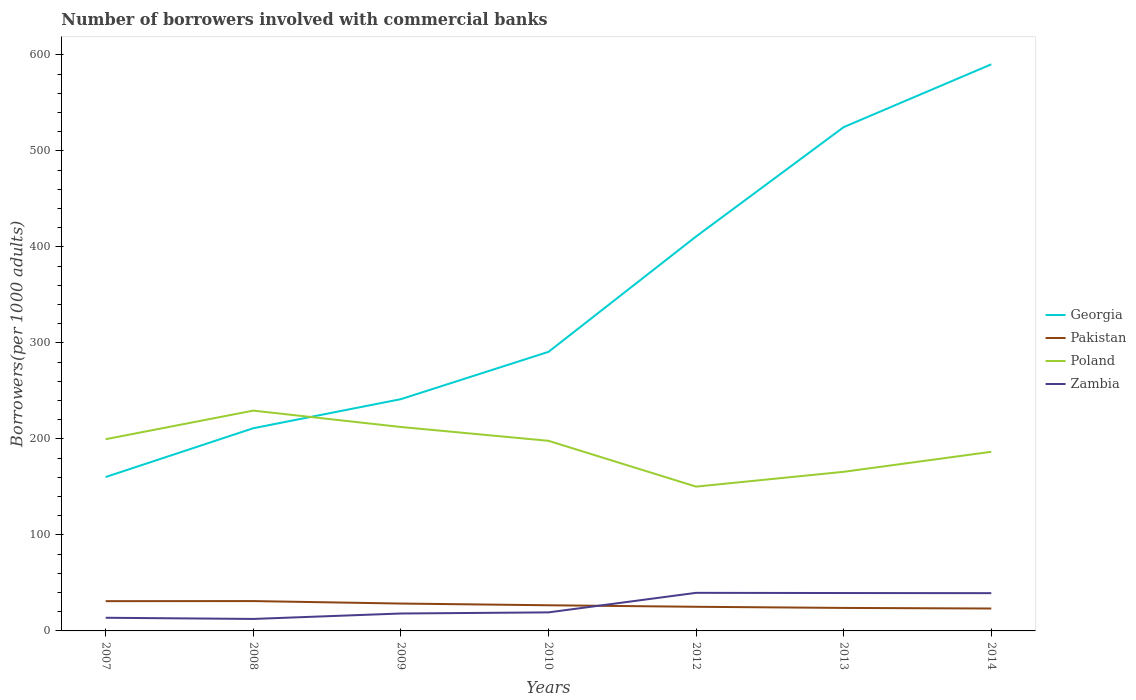Across all years, what is the maximum number of borrowers involved with commercial banks in Zambia?
Offer a very short reply. 12.48. In which year was the number of borrowers involved with commercial banks in Poland maximum?
Provide a short and direct response. 2012. What is the total number of borrowers involved with commercial banks in Zambia in the graph?
Provide a short and direct response. -25.97. What is the difference between the highest and the second highest number of borrowers involved with commercial banks in Zambia?
Ensure brevity in your answer.  27.2. What is the difference between the highest and the lowest number of borrowers involved with commercial banks in Poland?
Give a very brief answer. 4. Is the number of borrowers involved with commercial banks in Georgia strictly greater than the number of borrowers involved with commercial banks in Zambia over the years?
Provide a short and direct response. No. How many lines are there?
Ensure brevity in your answer.  4. How many years are there in the graph?
Provide a short and direct response. 7. Are the values on the major ticks of Y-axis written in scientific E-notation?
Provide a succinct answer. No. Does the graph contain any zero values?
Provide a short and direct response. No. How many legend labels are there?
Offer a terse response. 4. How are the legend labels stacked?
Provide a succinct answer. Vertical. What is the title of the graph?
Make the answer very short. Number of borrowers involved with commercial banks. Does "St. Kitts and Nevis" appear as one of the legend labels in the graph?
Provide a short and direct response. No. What is the label or title of the Y-axis?
Offer a terse response. Borrowers(per 1000 adults). What is the Borrowers(per 1000 adults) of Georgia in 2007?
Your answer should be compact. 160.33. What is the Borrowers(per 1000 adults) in Pakistan in 2007?
Provide a succinct answer. 31.01. What is the Borrowers(per 1000 adults) of Poland in 2007?
Provide a succinct answer. 199.74. What is the Borrowers(per 1000 adults) in Zambia in 2007?
Offer a terse response. 13.71. What is the Borrowers(per 1000 adults) of Georgia in 2008?
Offer a very short reply. 211.16. What is the Borrowers(per 1000 adults) of Pakistan in 2008?
Your answer should be compact. 31.09. What is the Borrowers(per 1000 adults) of Poland in 2008?
Keep it short and to the point. 229.51. What is the Borrowers(per 1000 adults) of Zambia in 2008?
Ensure brevity in your answer.  12.48. What is the Borrowers(per 1000 adults) in Georgia in 2009?
Your answer should be compact. 241.45. What is the Borrowers(per 1000 adults) in Pakistan in 2009?
Make the answer very short. 28.52. What is the Borrowers(per 1000 adults) of Poland in 2009?
Provide a short and direct response. 212.45. What is the Borrowers(per 1000 adults) of Zambia in 2009?
Provide a short and direct response. 18.15. What is the Borrowers(per 1000 adults) in Georgia in 2010?
Provide a succinct answer. 290.72. What is the Borrowers(per 1000 adults) of Pakistan in 2010?
Keep it short and to the point. 26.73. What is the Borrowers(per 1000 adults) of Poland in 2010?
Give a very brief answer. 198.06. What is the Borrowers(per 1000 adults) in Zambia in 2010?
Offer a terse response. 19.32. What is the Borrowers(per 1000 adults) in Georgia in 2012?
Make the answer very short. 410.92. What is the Borrowers(per 1000 adults) of Pakistan in 2012?
Provide a short and direct response. 25.15. What is the Borrowers(per 1000 adults) of Poland in 2012?
Give a very brief answer. 150.33. What is the Borrowers(per 1000 adults) of Zambia in 2012?
Offer a terse response. 39.68. What is the Borrowers(per 1000 adults) in Georgia in 2013?
Your answer should be very brief. 524.86. What is the Borrowers(per 1000 adults) of Pakistan in 2013?
Your response must be concise. 23.97. What is the Borrowers(per 1000 adults) of Poland in 2013?
Keep it short and to the point. 165.76. What is the Borrowers(per 1000 adults) of Zambia in 2013?
Give a very brief answer. 39.47. What is the Borrowers(per 1000 adults) in Georgia in 2014?
Offer a terse response. 590.3. What is the Borrowers(per 1000 adults) of Pakistan in 2014?
Your answer should be compact. 23.34. What is the Borrowers(per 1000 adults) in Poland in 2014?
Provide a succinct answer. 186.61. What is the Borrowers(per 1000 adults) of Zambia in 2014?
Your response must be concise. 39.34. Across all years, what is the maximum Borrowers(per 1000 adults) in Georgia?
Your answer should be very brief. 590.3. Across all years, what is the maximum Borrowers(per 1000 adults) in Pakistan?
Your answer should be very brief. 31.09. Across all years, what is the maximum Borrowers(per 1000 adults) of Poland?
Provide a succinct answer. 229.51. Across all years, what is the maximum Borrowers(per 1000 adults) of Zambia?
Ensure brevity in your answer.  39.68. Across all years, what is the minimum Borrowers(per 1000 adults) in Georgia?
Provide a succinct answer. 160.33. Across all years, what is the minimum Borrowers(per 1000 adults) of Pakistan?
Your answer should be compact. 23.34. Across all years, what is the minimum Borrowers(per 1000 adults) of Poland?
Keep it short and to the point. 150.33. Across all years, what is the minimum Borrowers(per 1000 adults) in Zambia?
Offer a terse response. 12.48. What is the total Borrowers(per 1000 adults) of Georgia in the graph?
Provide a short and direct response. 2429.75. What is the total Borrowers(per 1000 adults) in Pakistan in the graph?
Give a very brief answer. 189.81. What is the total Borrowers(per 1000 adults) in Poland in the graph?
Ensure brevity in your answer.  1342.47. What is the total Borrowers(per 1000 adults) in Zambia in the graph?
Offer a very short reply. 182.15. What is the difference between the Borrowers(per 1000 adults) in Georgia in 2007 and that in 2008?
Make the answer very short. -50.83. What is the difference between the Borrowers(per 1000 adults) of Pakistan in 2007 and that in 2008?
Offer a very short reply. -0.08. What is the difference between the Borrowers(per 1000 adults) of Poland in 2007 and that in 2008?
Your answer should be very brief. -29.78. What is the difference between the Borrowers(per 1000 adults) of Zambia in 2007 and that in 2008?
Your response must be concise. 1.22. What is the difference between the Borrowers(per 1000 adults) in Georgia in 2007 and that in 2009?
Your answer should be very brief. -81.12. What is the difference between the Borrowers(per 1000 adults) of Pakistan in 2007 and that in 2009?
Keep it short and to the point. 2.49. What is the difference between the Borrowers(per 1000 adults) of Poland in 2007 and that in 2009?
Your response must be concise. -12.71. What is the difference between the Borrowers(per 1000 adults) of Zambia in 2007 and that in 2009?
Your answer should be compact. -4.45. What is the difference between the Borrowers(per 1000 adults) in Georgia in 2007 and that in 2010?
Offer a very short reply. -130.39. What is the difference between the Borrowers(per 1000 adults) of Pakistan in 2007 and that in 2010?
Offer a very short reply. 4.29. What is the difference between the Borrowers(per 1000 adults) of Poland in 2007 and that in 2010?
Make the answer very short. 1.67. What is the difference between the Borrowers(per 1000 adults) in Zambia in 2007 and that in 2010?
Ensure brevity in your answer.  -5.62. What is the difference between the Borrowers(per 1000 adults) of Georgia in 2007 and that in 2012?
Give a very brief answer. -250.59. What is the difference between the Borrowers(per 1000 adults) in Pakistan in 2007 and that in 2012?
Your answer should be very brief. 5.87. What is the difference between the Borrowers(per 1000 adults) of Poland in 2007 and that in 2012?
Make the answer very short. 49.4. What is the difference between the Borrowers(per 1000 adults) of Zambia in 2007 and that in 2012?
Keep it short and to the point. -25.97. What is the difference between the Borrowers(per 1000 adults) in Georgia in 2007 and that in 2013?
Your answer should be compact. -364.53. What is the difference between the Borrowers(per 1000 adults) in Pakistan in 2007 and that in 2013?
Provide a short and direct response. 7.05. What is the difference between the Borrowers(per 1000 adults) in Poland in 2007 and that in 2013?
Your response must be concise. 33.97. What is the difference between the Borrowers(per 1000 adults) of Zambia in 2007 and that in 2013?
Give a very brief answer. -25.76. What is the difference between the Borrowers(per 1000 adults) in Georgia in 2007 and that in 2014?
Offer a terse response. -429.97. What is the difference between the Borrowers(per 1000 adults) of Pakistan in 2007 and that in 2014?
Provide a short and direct response. 7.67. What is the difference between the Borrowers(per 1000 adults) of Poland in 2007 and that in 2014?
Provide a succinct answer. 13.12. What is the difference between the Borrowers(per 1000 adults) of Zambia in 2007 and that in 2014?
Keep it short and to the point. -25.63. What is the difference between the Borrowers(per 1000 adults) of Georgia in 2008 and that in 2009?
Provide a short and direct response. -30.29. What is the difference between the Borrowers(per 1000 adults) in Pakistan in 2008 and that in 2009?
Give a very brief answer. 2.57. What is the difference between the Borrowers(per 1000 adults) of Poland in 2008 and that in 2009?
Offer a terse response. 17.07. What is the difference between the Borrowers(per 1000 adults) of Zambia in 2008 and that in 2009?
Provide a short and direct response. -5.67. What is the difference between the Borrowers(per 1000 adults) of Georgia in 2008 and that in 2010?
Your response must be concise. -79.56. What is the difference between the Borrowers(per 1000 adults) of Pakistan in 2008 and that in 2010?
Offer a very short reply. 4.36. What is the difference between the Borrowers(per 1000 adults) in Poland in 2008 and that in 2010?
Make the answer very short. 31.45. What is the difference between the Borrowers(per 1000 adults) in Zambia in 2008 and that in 2010?
Offer a terse response. -6.84. What is the difference between the Borrowers(per 1000 adults) in Georgia in 2008 and that in 2012?
Keep it short and to the point. -199.76. What is the difference between the Borrowers(per 1000 adults) in Pakistan in 2008 and that in 2012?
Keep it short and to the point. 5.94. What is the difference between the Borrowers(per 1000 adults) in Poland in 2008 and that in 2012?
Your response must be concise. 79.18. What is the difference between the Borrowers(per 1000 adults) of Zambia in 2008 and that in 2012?
Your answer should be compact. -27.2. What is the difference between the Borrowers(per 1000 adults) in Georgia in 2008 and that in 2013?
Provide a succinct answer. -313.7. What is the difference between the Borrowers(per 1000 adults) in Pakistan in 2008 and that in 2013?
Offer a terse response. 7.13. What is the difference between the Borrowers(per 1000 adults) in Poland in 2008 and that in 2013?
Offer a terse response. 63.75. What is the difference between the Borrowers(per 1000 adults) of Zambia in 2008 and that in 2013?
Your response must be concise. -26.98. What is the difference between the Borrowers(per 1000 adults) of Georgia in 2008 and that in 2014?
Your answer should be compact. -379.14. What is the difference between the Borrowers(per 1000 adults) in Pakistan in 2008 and that in 2014?
Provide a short and direct response. 7.75. What is the difference between the Borrowers(per 1000 adults) of Poland in 2008 and that in 2014?
Ensure brevity in your answer.  42.9. What is the difference between the Borrowers(per 1000 adults) in Zambia in 2008 and that in 2014?
Offer a very short reply. -26.86. What is the difference between the Borrowers(per 1000 adults) in Georgia in 2009 and that in 2010?
Provide a succinct answer. -49.27. What is the difference between the Borrowers(per 1000 adults) in Pakistan in 2009 and that in 2010?
Offer a terse response. 1.79. What is the difference between the Borrowers(per 1000 adults) in Poland in 2009 and that in 2010?
Provide a short and direct response. 14.38. What is the difference between the Borrowers(per 1000 adults) of Zambia in 2009 and that in 2010?
Provide a succinct answer. -1.17. What is the difference between the Borrowers(per 1000 adults) of Georgia in 2009 and that in 2012?
Your answer should be very brief. -169.47. What is the difference between the Borrowers(per 1000 adults) in Pakistan in 2009 and that in 2012?
Your answer should be very brief. 3.37. What is the difference between the Borrowers(per 1000 adults) in Poland in 2009 and that in 2012?
Offer a very short reply. 62.11. What is the difference between the Borrowers(per 1000 adults) of Zambia in 2009 and that in 2012?
Give a very brief answer. -21.52. What is the difference between the Borrowers(per 1000 adults) of Georgia in 2009 and that in 2013?
Your answer should be compact. -283.41. What is the difference between the Borrowers(per 1000 adults) in Pakistan in 2009 and that in 2013?
Offer a terse response. 4.55. What is the difference between the Borrowers(per 1000 adults) of Poland in 2009 and that in 2013?
Provide a short and direct response. 46.68. What is the difference between the Borrowers(per 1000 adults) of Zambia in 2009 and that in 2013?
Keep it short and to the point. -21.31. What is the difference between the Borrowers(per 1000 adults) of Georgia in 2009 and that in 2014?
Offer a terse response. -348.85. What is the difference between the Borrowers(per 1000 adults) of Pakistan in 2009 and that in 2014?
Keep it short and to the point. 5.18. What is the difference between the Borrowers(per 1000 adults) in Poland in 2009 and that in 2014?
Make the answer very short. 25.83. What is the difference between the Borrowers(per 1000 adults) of Zambia in 2009 and that in 2014?
Your answer should be compact. -21.19. What is the difference between the Borrowers(per 1000 adults) in Georgia in 2010 and that in 2012?
Your response must be concise. -120.2. What is the difference between the Borrowers(per 1000 adults) in Pakistan in 2010 and that in 2012?
Keep it short and to the point. 1.58. What is the difference between the Borrowers(per 1000 adults) in Poland in 2010 and that in 2012?
Your response must be concise. 47.73. What is the difference between the Borrowers(per 1000 adults) in Zambia in 2010 and that in 2012?
Keep it short and to the point. -20.36. What is the difference between the Borrowers(per 1000 adults) in Georgia in 2010 and that in 2013?
Offer a terse response. -234.14. What is the difference between the Borrowers(per 1000 adults) of Pakistan in 2010 and that in 2013?
Make the answer very short. 2.76. What is the difference between the Borrowers(per 1000 adults) of Poland in 2010 and that in 2013?
Provide a succinct answer. 32.3. What is the difference between the Borrowers(per 1000 adults) of Zambia in 2010 and that in 2013?
Make the answer very short. -20.14. What is the difference between the Borrowers(per 1000 adults) of Georgia in 2010 and that in 2014?
Your answer should be compact. -299.58. What is the difference between the Borrowers(per 1000 adults) of Pakistan in 2010 and that in 2014?
Your response must be concise. 3.39. What is the difference between the Borrowers(per 1000 adults) of Poland in 2010 and that in 2014?
Offer a very short reply. 11.45. What is the difference between the Borrowers(per 1000 adults) of Zambia in 2010 and that in 2014?
Keep it short and to the point. -20.02. What is the difference between the Borrowers(per 1000 adults) in Georgia in 2012 and that in 2013?
Keep it short and to the point. -113.94. What is the difference between the Borrowers(per 1000 adults) in Pakistan in 2012 and that in 2013?
Offer a very short reply. 1.18. What is the difference between the Borrowers(per 1000 adults) in Poland in 2012 and that in 2013?
Offer a terse response. -15.43. What is the difference between the Borrowers(per 1000 adults) in Zambia in 2012 and that in 2013?
Provide a short and direct response. 0.21. What is the difference between the Borrowers(per 1000 adults) in Georgia in 2012 and that in 2014?
Keep it short and to the point. -179.38. What is the difference between the Borrowers(per 1000 adults) of Pakistan in 2012 and that in 2014?
Keep it short and to the point. 1.81. What is the difference between the Borrowers(per 1000 adults) in Poland in 2012 and that in 2014?
Make the answer very short. -36.28. What is the difference between the Borrowers(per 1000 adults) in Zambia in 2012 and that in 2014?
Provide a short and direct response. 0.34. What is the difference between the Borrowers(per 1000 adults) in Georgia in 2013 and that in 2014?
Provide a succinct answer. -65.44. What is the difference between the Borrowers(per 1000 adults) of Pakistan in 2013 and that in 2014?
Your response must be concise. 0.63. What is the difference between the Borrowers(per 1000 adults) of Poland in 2013 and that in 2014?
Offer a terse response. -20.85. What is the difference between the Borrowers(per 1000 adults) in Zambia in 2013 and that in 2014?
Make the answer very short. 0.13. What is the difference between the Borrowers(per 1000 adults) in Georgia in 2007 and the Borrowers(per 1000 adults) in Pakistan in 2008?
Give a very brief answer. 129.24. What is the difference between the Borrowers(per 1000 adults) in Georgia in 2007 and the Borrowers(per 1000 adults) in Poland in 2008?
Provide a short and direct response. -69.18. What is the difference between the Borrowers(per 1000 adults) in Georgia in 2007 and the Borrowers(per 1000 adults) in Zambia in 2008?
Make the answer very short. 147.85. What is the difference between the Borrowers(per 1000 adults) in Pakistan in 2007 and the Borrowers(per 1000 adults) in Poland in 2008?
Provide a short and direct response. -198.5. What is the difference between the Borrowers(per 1000 adults) of Pakistan in 2007 and the Borrowers(per 1000 adults) of Zambia in 2008?
Give a very brief answer. 18.53. What is the difference between the Borrowers(per 1000 adults) of Poland in 2007 and the Borrowers(per 1000 adults) of Zambia in 2008?
Give a very brief answer. 187.25. What is the difference between the Borrowers(per 1000 adults) of Georgia in 2007 and the Borrowers(per 1000 adults) of Pakistan in 2009?
Your answer should be very brief. 131.81. What is the difference between the Borrowers(per 1000 adults) in Georgia in 2007 and the Borrowers(per 1000 adults) in Poland in 2009?
Give a very brief answer. -52.11. What is the difference between the Borrowers(per 1000 adults) in Georgia in 2007 and the Borrowers(per 1000 adults) in Zambia in 2009?
Provide a succinct answer. 142.18. What is the difference between the Borrowers(per 1000 adults) of Pakistan in 2007 and the Borrowers(per 1000 adults) of Poland in 2009?
Provide a succinct answer. -181.43. What is the difference between the Borrowers(per 1000 adults) in Pakistan in 2007 and the Borrowers(per 1000 adults) in Zambia in 2009?
Offer a very short reply. 12.86. What is the difference between the Borrowers(per 1000 adults) of Poland in 2007 and the Borrowers(per 1000 adults) of Zambia in 2009?
Offer a very short reply. 181.58. What is the difference between the Borrowers(per 1000 adults) of Georgia in 2007 and the Borrowers(per 1000 adults) of Pakistan in 2010?
Your response must be concise. 133.6. What is the difference between the Borrowers(per 1000 adults) of Georgia in 2007 and the Borrowers(per 1000 adults) of Poland in 2010?
Keep it short and to the point. -37.73. What is the difference between the Borrowers(per 1000 adults) in Georgia in 2007 and the Borrowers(per 1000 adults) in Zambia in 2010?
Give a very brief answer. 141.01. What is the difference between the Borrowers(per 1000 adults) of Pakistan in 2007 and the Borrowers(per 1000 adults) of Poland in 2010?
Provide a succinct answer. -167.05. What is the difference between the Borrowers(per 1000 adults) of Pakistan in 2007 and the Borrowers(per 1000 adults) of Zambia in 2010?
Offer a terse response. 11.69. What is the difference between the Borrowers(per 1000 adults) of Poland in 2007 and the Borrowers(per 1000 adults) of Zambia in 2010?
Provide a short and direct response. 180.41. What is the difference between the Borrowers(per 1000 adults) of Georgia in 2007 and the Borrowers(per 1000 adults) of Pakistan in 2012?
Provide a short and direct response. 135.19. What is the difference between the Borrowers(per 1000 adults) in Georgia in 2007 and the Borrowers(per 1000 adults) in Poland in 2012?
Make the answer very short. 10. What is the difference between the Borrowers(per 1000 adults) in Georgia in 2007 and the Borrowers(per 1000 adults) in Zambia in 2012?
Give a very brief answer. 120.66. What is the difference between the Borrowers(per 1000 adults) in Pakistan in 2007 and the Borrowers(per 1000 adults) in Poland in 2012?
Your response must be concise. -119.32. What is the difference between the Borrowers(per 1000 adults) of Pakistan in 2007 and the Borrowers(per 1000 adults) of Zambia in 2012?
Your answer should be compact. -8.66. What is the difference between the Borrowers(per 1000 adults) of Poland in 2007 and the Borrowers(per 1000 adults) of Zambia in 2012?
Provide a succinct answer. 160.06. What is the difference between the Borrowers(per 1000 adults) of Georgia in 2007 and the Borrowers(per 1000 adults) of Pakistan in 2013?
Ensure brevity in your answer.  136.37. What is the difference between the Borrowers(per 1000 adults) of Georgia in 2007 and the Borrowers(per 1000 adults) of Poland in 2013?
Provide a succinct answer. -5.43. What is the difference between the Borrowers(per 1000 adults) in Georgia in 2007 and the Borrowers(per 1000 adults) in Zambia in 2013?
Offer a very short reply. 120.87. What is the difference between the Borrowers(per 1000 adults) in Pakistan in 2007 and the Borrowers(per 1000 adults) in Poland in 2013?
Keep it short and to the point. -134.75. What is the difference between the Borrowers(per 1000 adults) in Pakistan in 2007 and the Borrowers(per 1000 adults) in Zambia in 2013?
Make the answer very short. -8.45. What is the difference between the Borrowers(per 1000 adults) in Poland in 2007 and the Borrowers(per 1000 adults) in Zambia in 2013?
Your answer should be compact. 160.27. What is the difference between the Borrowers(per 1000 adults) of Georgia in 2007 and the Borrowers(per 1000 adults) of Pakistan in 2014?
Make the answer very short. 136.99. What is the difference between the Borrowers(per 1000 adults) in Georgia in 2007 and the Borrowers(per 1000 adults) in Poland in 2014?
Make the answer very short. -26.28. What is the difference between the Borrowers(per 1000 adults) of Georgia in 2007 and the Borrowers(per 1000 adults) of Zambia in 2014?
Give a very brief answer. 120.99. What is the difference between the Borrowers(per 1000 adults) in Pakistan in 2007 and the Borrowers(per 1000 adults) in Poland in 2014?
Keep it short and to the point. -155.6. What is the difference between the Borrowers(per 1000 adults) in Pakistan in 2007 and the Borrowers(per 1000 adults) in Zambia in 2014?
Offer a very short reply. -8.32. What is the difference between the Borrowers(per 1000 adults) of Poland in 2007 and the Borrowers(per 1000 adults) of Zambia in 2014?
Your answer should be compact. 160.4. What is the difference between the Borrowers(per 1000 adults) of Georgia in 2008 and the Borrowers(per 1000 adults) of Pakistan in 2009?
Ensure brevity in your answer.  182.64. What is the difference between the Borrowers(per 1000 adults) in Georgia in 2008 and the Borrowers(per 1000 adults) in Poland in 2009?
Your answer should be compact. -1.29. What is the difference between the Borrowers(per 1000 adults) in Georgia in 2008 and the Borrowers(per 1000 adults) in Zambia in 2009?
Provide a short and direct response. 193.01. What is the difference between the Borrowers(per 1000 adults) in Pakistan in 2008 and the Borrowers(per 1000 adults) in Poland in 2009?
Your response must be concise. -181.36. What is the difference between the Borrowers(per 1000 adults) in Pakistan in 2008 and the Borrowers(per 1000 adults) in Zambia in 2009?
Ensure brevity in your answer.  12.94. What is the difference between the Borrowers(per 1000 adults) in Poland in 2008 and the Borrowers(per 1000 adults) in Zambia in 2009?
Offer a very short reply. 211.36. What is the difference between the Borrowers(per 1000 adults) of Georgia in 2008 and the Borrowers(per 1000 adults) of Pakistan in 2010?
Your response must be concise. 184.43. What is the difference between the Borrowers(per 1000 adults) in Georgia in 2008 and the Borrowers(per 1000 adults) in Poland in 2010?
Keep it short and to the point. 13.1. What is the difference between the Borrowers(per 1000 adults) in Georgia in 2008 and the Borrowers(per 1000 adults) in Zambia in 2010?
Give a very brief answer. 191.84. What is the difference between the Borrowers(per 1000 adults) in Pakistan in 2008 and the Borrowers(per 1000 adults) in Poland in 2010?
Provide a short and direct response. -166.97. What is the difference between the Borrowers(per 1000 adults) in Pakistan in 2008 and the Borrowers(per 1000 adults) in Zambia in 2010?
Your response must be concise. 11.77. What is the difference between the Borrowers(per 1000 adults) of Poland in 2008 and the Borrowers(per 1000 adults) of Zambia in 2010?
Ensure brevity in your answer.  210.19. What is the difference between the Borrowers(per 1000 adults) of Georgia in 2008 and the Borrowers(per 1000 adults) of Pakistan in 2012?
Your answer should be compact. 186.01. What is the difference between the Borrowers(per 1000 adults) in Georgia in 2008 and the Borrowers(per 1000 adults) in Poland in 2012?
Ensure brevity in your answer.  60.83. What is the difference between the Borrowers(per 1000 adults) in Georgia in 2008 and the Borrowers(per 1000 adults) in Zambia in 2012?
Give a very brief answer. 171.48. What is the difference between the Borrowers(per 1000 adults) of Pakistan in 2008 and the Borrowers(per 1000 adults) of Poland in 2012?
Offer a very short reply. -119.24. What is the difference between the Borrowers(per 1000 adults) in Pakistan in 2008 and the Borrowers(per 1000 adults) in Zambia in 2012?
Your response must be concise. -8.59. What is the difference between the Borrowers(per 1000 adults) in Poland in 2008 and the Borrowers(per 1000 adults) in Zambia in 2012?
Ensure brevity in your answer.  189.84. What is the difference between the Borrowers(per 1000 adults) of Georgia in 2008 and the Borrowers(per 1000 adults) of Pakistan in 2013?
Your response must be concise. 187.19. What is the difference between the Borrowers(per 1000 adults) of Georgia in 2008 and the Borrowers(per 1000 adults) of Poland in 2013?
Offer a terse response. 45.4. What is the difference between the Borrowers(per 1000 adults) of Georgia in 2008 and the Borrowers(per 1000 adults) of Zambia in 2013?
Your answer should be compact. 171.69. What is the difference between the Borrowers(per 1000 adults) in Pakistan in 2008 and the Borrowers(per 1000 adults) in Poland in 2013?
Ensure brevity in your answer.  -134.67. What is the difference between the Borrowers(per 1000 adults) in Pakistan in 2008 and the Borrowers(per 1000 adults) in Zambia in 2013?
Provide a short and direct response. -8.37. What is the difference between the Borrowers(per 1000 adults) in Poland in 2008 and the Borrowers(per 1000 adults) in Zambia in 2013?
Provide a succinct answer. 190.05. What is the difference between the Borrowers(per 1000 adults) in Georgia in 2008 and the Borrowers(per 1000 adults) in Pakistan in 2014?
Offer a terse response. 187.82. What is the difference between the Borrowers(per 1000 adults) of Georgia in 2008 and the Borrowers(per 1000 adults) of Poland in 2014?
Your answer should be compact. 24.54. What is the difference between the Borrowers(per 1000 adults) of Georgia in 2008 and the Borrowers(per 1000 adults) of Zambia in 2014?
Keep it short and to the point. 171.82. What is the difference between the Borrowers(per 1000 adults) in Pakistan in 2008 and the Borrowers(per 1000 adults) in Poland in 2014?
Your answer should be very brief. -155.52. What is the difference between the Borrowers(per 1000 adults) of Pakistan in 2008 and the Borrowers(per 1000 adults) of Zambia in 2014?
Your answer should be very brief. -8.25. What is the difference between the Borrowers(per 1000 adults) of Poland in 2008 and the Borrowers(per 1000 adults) of Zambia in 2014?
Your answer should be very brief. 190.17. What is the difference between the Borrowers(per 1000 adults) of Georgia in 2009 and the Borrowers(per 1000 adults) of Pakistan in 2010?
Provide a short and direct response. 214.72. What is the difference between the Borrowers(per 1000 adults) of Georgia in 2009 and the Borrowers(per 1000 adults) of Poland in 2010?
Make the answer very short. 43.39. What is the difference between the Borrowers(per 1000 adults) in Georgia in 2009 and the Borrowers(per 1000 adults) in Zambia in 2010?
Provide a succinct answer. 222.13. What is the difference between the Borrowers(per 1000 adults) of Pakistan in 2009 and the Borrowers(per 1000 adults) of Poland in 2010?
Your answer should be very brief. -169.54. What is the difference between the Borrowers(per 1000 adults) of Pakistan in 2009 and the Borrowers(per 1000 adults) of Zambia in 2010?
Make the answer very short. 9.2. What is the difference between the Borrowers(per 1000 adults) in Poland in 2009 and the Borrowers(per 1000 adults) in Zambia in 2010?
Your response must be concise. 193.13. What is the difference between the Borrowers(per 1000 adults) in Georgia in 2009 and the Borrowers(per 1000 adults) in Pakistan in 2012?
Give a very brief answer. 216.3. What is the difference between the Borrowers(per 1000 adults) of Georgia in 2009 and the Borrowers(per 1000 adults) of Poland in 2012?
Provide a succinct answer. 91.12. What is the difference between the Borrowers(per 1000 adults) of Georgia in 2009 and the Borrowers(per 1000 adults) of Zambia in 2012?
Offer a very short reply. 201.77. What is the difference between the Borrowers(per 1000 adults) in Pakistan in 2009 and the Borrowers(per 1000 adults) in Poland in 2012?
Give a very brief answer. -121.81. What is the difference between the Borrowers(per 1000 adults) in Pakistan in 2009 and the Borrowers(per 1000 adults) in Zambia in 2012?
Provide a short and direct response. -11.16. What is the difference between the Borrowers(per 1000 adults) in Poland in 2009 and the Borrowers(per 1000 adults) in Zambia in 2012?
Give a very brief answer. 172.77. What is the difference between the Borrowers(per 1000 adults) in Georgia in 2009 and the Borrowers(per 1000 adults) in Pakistan in 2013?
Give a very brief answer. 217.49. What is the difference between the Borrowers(per 1000 adults) of Georgia in 2009 and the Borrowers(per 1000 adults) of Poland in 2013?
Keep it short and to the point. 75.69. What is the difference between the Borrowers(per 1000 adults) in Georgia in 2009 and the Borrowers(per 1000 adults) in Zambia in 2013?
Your answer should be compact. 201.98. What is the difference between the Borrowers(per 1000 adults) of Pakistan in 2009 and the Borrowers(per 1000 adults) of Poland in 2013?
Keep it short and to the point. -137.24. What is the difference between the Borrowers(per 1000 adults) of Pakistan in 2009 and the Borrowers(per 1000 adults) of Zambia in 2013?
Your answer should be compact. -10.95. What is the difference between the Borrowers(per 1000 adults) in Poland in 2009 and the Borrowers(per 1000 adults) in Zambia in 2013?
Provide a succinct answer. 172.98. What is the difference between the Borrowers(per 1000 adults) in Georgia in 2009 and the Borrowers(per 1000 adults) in Pakistan in 2014?
Offer a very short reply. 218.11. What is the difference between the Borrowers(per 1000 adults) of Georgia in 2009 and the Borrowers(per 1000 adults) of Poland in 2014?
Offer a very short reply. 54.84. What is the difference between the Borrowers(per 1000 adults) in Georgia in 2009 and the Borrowers(per 1000 adults) in Zambia in 2014?
Offer a very short reply. 202.11. What is the difference between the Borrowers(per 1000 adults) of Pakistan in 2009 and the Borrowers(per 1000 adults) of Poland in 2014?
Make the answer very short. -158.09. What is the difference between the Borrowers(per 1000 adults) in Pakistan in 2009 and the Borrowers(per 1000 adults) in Zambia in 2014?
Your answer should be compact. -10.82. What is the difference between the Borrowers(per 1000 adults) of Poland in 2009 and the Borrowers(per 1000 adults) of Zambia in 2014?
Your response must be concise. 173.11. What is the difference between the Borrowers(per 1000 adults) of Georgia in 2010 and the Borrowers(per 1000 adults) of Pakistan in 2012?
Offer a terse response. 265.58. What is the difference between the Borrowers(per 1000 adults) in Georgia in 2010 and the Borrowers(per 1000 adults) in Poland in 2012?
Make the answer very short. 140.39. What is the difference between the Borrowers(per 1000 adults) of Georgia in 2010 and the Borrowers(per 1000 adults) of Zambia in 2012?
Your answer should be very brief. 251.05. What is the difference between the Borrowers(per 1000 adults) in Pakistan in 2010 and the Borrowers(per 1000 adults) in Poland in 2012?
Give a very brief answer. -123.6. What is the difference between the Borrowers(per 1000 adults) in Pakistan in 2010 and the Borrowers(per 1000 adults) in Zambia in 2012?
Make the answer very short. -12.95. What is the difference between the Borrowers(per 1000 adults) of Poland in 2010 and the Borrowers(per 1000 adults) of Zambia in 2012?
Your answer should be very brief. 158.39. What is the difference between the Borrowers(per 1000 adults) of Georgia in 2010 and the Borrowers(per 1000 adults) of Pakistan in 2013?
Ensure brevity in your answer.  266.76. What is the difference between the Borrowers(per 1000 adults) in Georgia in 2010 and the Borrowers(per 1000 adults) in Poland in 2013?
Keep it short and to the point. 124.96. What is the difference between the Borrowers(per 1000 adults) of Georgia in 2010 and the Borrowers(per 1000 adults) of Zambia in 2013?
Make the answer very short. 251.26. What is the difference between the Borrowers(per 1000 adults) in Pakistan in 2010 and the Borrowers(per 1000 adults) in Poland in 2013?
Give a very brief answer. -139.03. What is the difference between the Borrowers(per 1000 adults) of Pakistan in 2010 and the Borrowers(per 1000 adults) of Zambia in 2013?
Keep it short and to the point. -12.74. What is the difference between the Borrowers(per 1000 adults) of Poland in 2010 and the Borrowers(per 1000 adults) of Zambia in 2013?
Provide a short and direct response. 158.6. What is the difference between the Borrowers(per 1000 adults) of Georgia in 2010 and the Borrowers(per 1000 adults) of Pakistan in 2014?
Make the answer very short. 267.38. What is the difference between the Borrowers(per 1000 adults) of Georgia in 2010 and the Borrowers(per 1000 adults) of Poland in 2014?
Provide a succinct answer. 104.11. What is the difference between the Borrowers(per 1000 adults) in Georgia in 2010 and the Borrowers(per 1000 adults) in Zambia in 2014?
Give a very brief answer. 251.38. What is the difference between the Borrowers(per 1000 adults) in Pakistan in 2010 and the Borrowers(per 1000 adults) in Poland in 2014?
Give a very brief answer. -159.89. What is the difference between the Borrowers(per 1000 adults) of Pakistan in 2010 and the Borrowers(per 1000 adults) of Zambia in 2014?
Your answer should be very brief. -12.61. What is the difference between the Borrowers(per 1000 adults) in Poland in 2010 and the Borrowers(per 1000 adults) in Zambia in 2014?
Offer a very short reply. 158.72. What is the difference between the Borrowers(per 1000 adults) in Georgia in 2012 and the Borrowers(per 1000 adults) in Pakistan in 2013?
Offer a very short reply. 386.96. What is the difference between the Borrowers(per 1000 adults) in Georgia in 2012 and the Borrowers(per 1000 adults) in Poland in 2013?
Keep it short and to the point. 245.16. What is the difference between the Borrowers(per 1000 adults) of Georgia in 2012 and the Borrowers(per 1000 adults) of Zambia in 2013?
Your answer should be very brief. 371.46. What is the difference between the Borrowers(per 1000 adults) of Pakistan in 2012 and the Borrowers(per 1000 adults) of Poland in 2013?
Ensure brevity in your answer.  -140.62. What is the difference between the Borrowers(per 1000 adults) of Pakistan in 2012 and the Borrowers(per 1000 adults) of Zambia in 2013?
Offer a very short reply. -14.32. What is the difference between the Borrowers(per 1000 adults) in Poland in 2012 and the Borrowers(per 1000 adults) in Zambia in 2013?
Offer a very short reply. 110.87. What is the difference between the Borrowers(per 1000 adults) in Georgia in 2012 and the Borrowers(per 1000 adults) in Pakistan in 2014?
Provide a short and direct response. 387.58. What is the difference between the Borrowers(per 1000 adults) in Georgia in 2012 and the Borrowers(per 1000 adults) in Poland in 2014?
Your answer should be compact. 224.31. What is the difference between the Borrowers(per 1000 adults) of Georgia in 2012 and the Borrowers(per 1000 adults) of Zambia in 2014?
Offer a very short reply. 371.58. What is the difference between the Borrowers(per 1000 adults) in Pakistan in 2012 and the Borrowers(per 1000 adults) in Poland in 2014?
Ensure brevity in your answer.  -161.47. What is the difference between the Borrowers(per 1000 adults) in Pakistan in 2012 and the Borrowers(per 1000 adults) in Zambia in 2014?
Keep it short and to the point. -14.19. What is the difference between the Borrowers(per 1000 adults) of Poland in 2012 and the Borrowers(per 1000 adults) of Zambia in 2014?
Your answer should be compact. 110.99. What is the difference between the Borrowers(per 1000 adults) of Georgia in 2013 and the Borrowers(per 1000 adults) of Pakistan in 2014?
Offer a very short reply. 501.52. What is the difference between the Borrowers(per 1000 adults) of Georgia in 2013 and the Borrowers(per 1000 adults) of Poland in 2014?
Provide a succinct answer. 338.25. What is the difference between the Borrowers(per 1000 adults) of Georgia in 2013 and the Borrowers(per 1000 adults) of Zambia in 2014?
Provide a short and direct response. 485.52. What is the difference between the Borrowers(per 1000 adults) in Pakistan in 2013 and the Borrowers(per 1000 adults) in Poland in 2014?
Ensure brevity in your answer.  -162.65. What is the difference between the Borrowers(per 1000 adults) in Pakistan in 2013 and the Borrowers(per 1000 adults) in Zambia in 2014?
Ensure brevity in your answer.  -15.37. What is the difference between the Borrowers(per 1000 adults) in Poland in 2013 and the Borrowers(per 1000 adults) in Zambia in 2014?
Your answer should be compact. 126.42. What is the average Borrowers(per 1000 adults) in Georgia per year?
Provide a short and direct response. 347.11. What is the average Borrowers(per 1000 adults) in Pakistan per year?
Give a very brief answer. 27.12. What is the average Borrowers(per 1000 adults) in Poland per year?
Offer a very short reply. 191.78. What is the average Borrowers(per 1000 adults) in Zambia per year?
Offer a very short reply. 26.02. In the year 2007, what is the difference between the Borrowers(per 1000 adults) of Georgia and Borrowers(per 1000 adults) of Pakistan?
Your answer should be very brief. 129.32. In the year 2007, what is the difference between the Borrowers(per 1000 adults) of Georgia and Borrowers(per 1000 adults) of Poland?
Give a very brief answer. -39.4. In the year 2007, what is the difference between the Borrowers(per 1000 adults) in Georgia and Borrowers(per 1000 adults) in Zambia?
Offer a very short reply. 146.63. In the year 2007, what is the difference between the Borrowers(per 1000 adults) of Pakistan and Borrowers(per 1000 adults) of Poland?
Offer a terse response. -168.72. In the year 2007, what is the difference between the Borrowers(per 1000 adults) in Pakistan and Borrowers(per 1000 adults) in Zambia?
Offer a very short reply. 17.31. In the year 2007, what is the difference between the Borrowers(per 1000 adults) of Poland and Borrowers(per 1000 adults) of Zambia?
Give a very brief answer. 186.03. In the year 2008, what is the difference between the Borrowers(per 1000 adults) of Georgia and Borrowers(per 1000 adults) of Pakistan?
Make the answer very short. 180.07. In the year 2008, what is the difference between the Borrowers(per 1000 adults) of Georgia and Borrowers(per 1000 adults) of Poland?
Provide a short and direct response. -18.35. In the year 2008, what is the difference between the Borrowers(per 1000 adults) of Georgia and Borrowers(per 1000 adults) of Zambia?
Your response must be concise. 198.68. In the year 2008, what is the difference between the Borrowers(per 1000 adults) of Pakistan and Borrowers(per 1000 adults) of Poland?
Your answer should be very brief. -198.42. In the year 2008, what is the difference between the Borrowers(per 1000 adults) of Pakistan and Borrowers(per 1000 adults) of Zambia?
Your answer should be compact. 18.61. In the year 2008, what is the difference between the Borrowers(per 1000 adults) of Poland and Borrowers(per 1000 adults) of Zambia?
Your answer should be compact. 217.03. In the year 2009, what is the difference between the Borrowers(per 1000 adults) of Georgia and Borrowers(per 1000 adults) of Pakistan?
Keep it short and to the point. 212.93. In the year 2009, what is the difference between the Borrowers(per 1000 adults) in Georgia and Borrowers(per 1000 adults) in Poland?
Provide a succinct answer. 29. In the year 2009, what is the difference between the Borrowers(per 1000 adults) of Georgia and Borrowers(per 1000 adults) of Zambia?
Keep it short and to the point. 223.3. In the year 2009, what is the difference between the Borrowers(per 1000 adults) of Pakistan and Borrowers(per 1000 adults) of Poland?
Provide a succinct answer. -183.93. In the year 2009, what is the difference between the Borrowers(per 1000 adults) in Pakistan and Borrowers(per 1000 adults) in Zambia?
Provide a succinct answer. 10.37. In the year 2009, what is the difference between the Borrowers(per 1000 adults) of Poland and Borrowers(per 1000 adults) of Zambia?
Your answer should be very brief. 194.29. In the year 2010, what is the difference between the Borrowers(per 1000 adults) in Georgia and Borrowers(per 1000 adults) in Pakistan?
Your answer should be compact. 263.99. In the year 2010, what is the difference between the Borrowers(per 1000 adults) in Georgia and Borrowers(per 1000 adults) in Poland?
Give a very brief answer. 92.66. In the year 2010, what is the difference between the Borrowers(per 1000 adults) of Georgia and Borrowers(per 1000 adults) of Zambia?
Offer a terse response. 271.4. In the year 2010, what is the difference between the Borrowers(per 1000 adults) of Pakistan and Borrowers(per 1000 adults) of Poland?
Your response must be concise. -171.34. In the year 2010, what is the difference between the Borrowers(per 1000 adults) of Pakistan and Borrowers(per 1000 adults) of Zambia?
Offer a terse response. 7.41. In the year 2010, what is the difference between the Borrowers(per 1000 adults) of Poland and Borrowers(per 1000 adults) of Zambia?
Ensure brevity in your answer.  178.74. In the year 2012, what is the difference between the Borrowers(per 1000 adults) in Georgia and Borrowers(per 1000 adults) in Pakistan?
Offer a very short reply. 385.77. In the year 2012, what is the difference between the Borrowers(per 1000 adults) in Georgia and Borrowers(per 1000 adults) in Poland?
Offer a terse response. 260.59. In the year 2012, what is the difference between the Borrowers(per 1000 adults) of Georgia and Borrowers(per 1000 adults) of Zambia?
Your response must be concise. 371.24. In the year 2012, what is the difference between the Borrowers(per 1000 adults) of Pakistan and Borrowers(per 1000 adults) of Poland?
Your response must be concise. -125.19. In the year 2012, what is the difference between the Borrowers(per 1000 adults) of Pakistan and Borrowers(per 1000 adults) of Zambia?
Provide a succinct answer. -14.53. In the year 2012, what is the difference between the Borrowers(per 1000 adults) of Poland and Borrowers(per 1000 adults) of Zambia?
Provide a succinct answer. 110.66. In the year 2013, what is the difference between the Borrowers(per 1000 adults) of Georgia and Borrowers(per 1000 adults) of Pakistan?
Give a very brief answer. 500.9. In the year 2013, what is the difference between the Borrowers(per 1000 adults) in Georgia and Borrowers(per 1000 adults) in Poland?
Offer a very short reply. 359.1. In the year 2013, what is the difference between the Borrowers(per 1000 adults) in Georgia and Borrowers(per 1000 adults) in Zambia?
Your answer should be very brief. 485.4. In the year 2013, what is the difference between the Borrowers(per 1000 adults) in Pakistan and Borrowers(per 1000 adults) in Poland?
Offer a terse response. -141.8. In the year 2013, what is the difference between the Borrowers(per 1000 adults) of Pakistan and Borrowers(per 1000 adults) of Zambia?
Your response must be concise. -15.5. In the year 2013, what is the difference between the Borrowers(per 1000 adults) of Poland and Borrowers(per 1000 adults) of Zambia?
Offer a very short reply. 126.3. In the year 2014, what is the difference between the Borrowers(per 1000 adults) of Georgia and Borrowers(per 1000 adults) of Pakistan?
Ensure brevity in your answer.  566.96. In the year 2014, what is the difference between the Borrowers(per 1000 adults) in Georgia and Borrowers(per 1000 adults) in Poland?
Ensure brevity in your answer.  403.69. In the year 2014, what is the difference between the Borrowers(per 1000 adults) in Georgia and Borrowers(per 1000 adults) in Zambia?
Offer a very short reply. 550.96. In the year 2014, what is the difference between the Borrowers(per 1000 adults) in Pakistan and Borrowers(per 1000 adults) in Poland?
Your response must be concise. -163.27. In the year 2014, what is the difference between the Borrowers(per 1000 adults) in Pakistan and Borrowers(per 1000 adults) in Zambia?
Give a very brief answer. -16. In the year 2014, what is the difference between the Borrowers(per 1000 adults) of Poland and Borrowers(per 1000 adults) of Zambia?
Offer a very short reply. 147.28. What is the ratio of the Borrowers(per 1000 adults) of Georgia in 2007 to that in 2008?
Your answer should be compact. 0.76. What is the ratio of the Borrowers(per 1000 adults) in Poland in 2007 to that in 2008?
Offer a terse response. 0.87. What is the ratio of the Borrowers(per 1000 adults) of Zambia in 2007 to that in 2008?
Provide a succinct answer. 1.1. What is the ratio of the Borrowers(per 1000 adults) in Georgia in 2007 to that in 2009?
Make the answer very short. 0.66. What is the ratio of the Borrowers(per 1000 adults) of Pakistan in 2007 to that in 2009?
Your response must be concise. 1.09. What is the ratio of the Borrowers(per 1000 adults) in Poland in 2007 to that in 2009?
Provide a short and direct response. 0.94. What is the ratio of the Borrowers(per 1000 adults) in Zambia in 2007 to that in 2009?
Provide a succinct answer. 0.76. What is the ratio of the Borrowers(per 1000 adults) in Georgia in 2007 to that in 2010?
Offer a very short reply. 0.55. What is the ratio of the Borrowers(per 1000 adults) in Pakistan in 2007 to that in 2010?
Ensure brevity in your answer.  1.16. What is the ratio of the Borrowers(per 1000 adults) of Poland in 2007 to that in 2010?
Your answer should be very brief. 1.01. What is the ratio of the Borrowers(per 1000 adults) in Zambia in 2007 to that in 2010?
Your answer should be compact. 0.71. What is the ratio of the Borrowers(per 1000 adults) of Georgia in 2007 to that in 2012?
Provide a succinct answer. 0.39. What is the ratio of the Borrowers(per 1000 adults) of Pakistan in 2007 to that in 2012?
Your answer should be compact. 1.23. What is the ratio of the Borrowers(per 1000 adults) of Poland in 2007 to that in 2012?
Your response must be concise. 1.33. What is the ratio of the Borrowers(per 1000 adults) in Zambia in 2007 to that in 2012?
Offer a terse response. 0.35. What is the ratio of the Borrowers(per 1000 adults) in Georgia in 2007 to that in 2013?
Give a very brief answer. 0.31. What is the ratio of the Borrowers(per 1000 adults) of Pakistan in 2007 to that in 2013?
Your response must be concise. 1.29. What is the ratio of the Borrowers(per 1000 adults) in Poland in 2007 to that in 2013?
Keep it short and to the point. 1.2. What is the ratio of the Borrowers(per 1000 adults) in Zambia in 2007 to that in 2013?
Offer a very short reply. 0.35. What is the ratio of the Borrowers(per 1000 adults) in Georgia in 2007 to that in 2014?
Ensure brevity in your answer.  0.27. What is the ratio of the Borrowers(per 1000 adults) of Pakistan in 2007 to that in 2014?
Give a very brief answer. 1.33. What is the ratio of the Borrowers(per 1000 adults) of Poland in 2007 to that in 2014?
Your answer should be compact. 1.07. What is the ratio of the Borrowers(per 1000 adults) in Zambia in 2007 to that in 2014?
Offer a very short reply. 0.35. What is the ratio of the Borrowers(per 1000 adults) of Georgia in 2008 to that in 2009?
Your answer should be compact. 0.87. What is the ratio of the Borrowers(per 1000 adults) in Pakistan in 2008 to that in 2009?
Offer a terse response. 1.09. What is the ratio of the Borrowers(per 1000 adults) in Poland in 2008 to that in 2009?
Provide a succinct answer. 1.08. What is the ratio of the Borrowers(per 1000 adults) in Zambia in 2008 to that in 2009?
Offer a terse response. 0.69. What is the ratio of the Borrowers(per 1000 adults) in Georgia in 2008 to that in 2010?
Provide a short and direct response. 0.73. What is the ratio of the Borrowers(per 1000 adults) in Pakistan in 2008 to that in 2010?
Keep it short and to the point. 1.16. What is the ratio of the Borrowers(per 1000 adults) of Poland in 2008 to that in 2010?
Make the answer very short. 1.16. What is the ratio of the Borrowers(per 1000 adults) in Zambia in 2008 to that in 2010?
Provide a short and direct response. 0.65. What is the ratio of the Borrowers(per 1000 adults) in Georgia in 2008 to that in 2012?
Give a very brief answer. 0.51. What is the ratio of the Borrowers(per 1000 adults) in Pakistan in 2008 to that in 2012?
Ensure brevity in your answer.  1.24. What is the ratio of the Borrowers(per 1000 adults) of Poland in 2008 to that in 2012?
Your answer should be very brief. 1.53. What is the ratio of the Borrowers(per 1000 adults) of Zambia in 2008 to that in 2012?
Ensure brevity in your answer.  0.31. What is the ratio of the Borrowers(per 1000 adults) of Georgia in 2008 to that in 2013?
Provide a short and direct response. 0.4. What is the ratio of the Borrowers(per 1000 adults) of Pakistan in 2008 to that in 2013?
Your answer should be very brief. 1.3. What is the ratio of the Borrowers(per 1000 adults) of Poland in 2008 to that in 2013?
Give a very brief answer. 1.38. What is the ratio of the Borrowers(per 1000 adults) of Zambia in 2008 to that in 2013?
Provide a short and direct response. 0.32. What is the ratio of the Borrowers(per 1000 adults) of Georgia in 2008 to that in 2014?
Give a very brief answer. 0.36. What is the ratio of the Borrowers(per 1000 adults) in Pakistan in 2008 to that in 2014?
Your answer should be very brief. 1.33. What is the ratio of the Borrowers(per 1000 adults) of Poland in 2008 to that in 2014?
Your response must be concise. 1.23. What is the ratio of the Borrowers(per 1000 adults) of Zambia in 2008 to that in 2014?
Your answer should be very brief. 0.32. What is the ratio of the Borrowers(per 1000 adults) in Georgia in 2009 to that in 2010?
Provide a succinct answer. 0.83. What is the ratio of the Borrowers(per 1000 adults) of Pakistan in 2009 to that in 2010?
Offer a terse response. 1.07. What is the ratio of the Borrowers(per 1000 adults) in Poland in 2009 to that in 2010?
Your response must be concise. 1.07. What is the ratio of the Borrowers(per 1000 adults) in Zambia in 2009 to that in 2010?
Your answer should be very brief. 0.94. What is the ratio of the Borrowers(per 1000 adults) in Georgia in 2009 to that in 2012?
Your answer should be very brief. 0.59. What is the ratio of the Borrowers(per 1000 adults) of Pakistan in 2009 to that in 2012?
Offer a very short reply. 1.13. What is the ratio of the Borrowers(per 1000 adults) in Poland in 2009 to that in 2012?
Your answer should be very brief. 1.41. What is the ratio of the Borrowers(per 1000 adults) of Zambia in 2009 to that in 2012?
Provide a succinct answer. 0.46. What is the ratio of the Borrowers(per 1000 adults) in Georgia in 2009 to that in 2013?
Your answer should be compact. 0.46. What is the ratio of the Borrowers(per 1000 adults) in Pakistan in 2009 to that in 2013?
Your answer should be very brief. 1.19. What is the ratio of the Borrowers(per 1000 adults) in Poland in 2009 to that in 2013?
Ensure brevity in your answer.  1.28. What is the ratio of the Borrowers(per 1000 adults) in Zambia in 2009 to that in 2013?
Provide a short and direct response. 0.46. What is the ratio of the Borrowers(per 1000 adults) of Georgia in 2009 to that in 2014?
Offer a terse response. 0.41. What is the ratio of the Borrowers(per 1000 adults) in Pakistan in 2009 to that in 2014?
Offer a terse response. 1.22. What is the ratio of the Borrowers(per 1000 adults) in Poland in 2009 to that in 2014?
Your answer should be very brief. 1.14. What is the ratio of the Borrowers(per 1000 adults) of Zambia in 2009 to that in 2014?
Offer a very short reply. 0.46. What is the ratio of the Borrowers(per 1000 adults) of Georgia in 2010 to that in 2012?
Provide a succinct answer. 0.71. What is the ratio of the Borrowers(per 1000 adults) of Pakistan in 2010 to that in 2012?
Provide a short and direct response. 1.06. What is the ratio of the Borrowers(per 1000 adults) of Poland in 2010 to that in 2012?
Offer a terse response. 1.32. What is the ratio of the Borrowers(per 1000 adults) in Zambia in 2010 to that in 2012?
Keep it short and to the point. 0.49. What is the ratio of the Borrowers(per 1000 adults) in Georgia in 2010 to that in 2013?
Offer a terse response. 0.55. What is the ratio of the Borrowers(per 1000 adults) of Pakistan in 2010 to that in 2013?
Make the answer very short. 1.12. What is the ratio of the Borrowers(per 1000 adults) in Poland in 2010 to that in 2013?
Provide a succinct answer. 1.19. What is the ratio of the Borrowers(per 1000 adults) of Zambia in 2010 to that in 2013?
Give a very brief answer. 0.49. What is the ratio of the Borrowers(per 1000 adults) of Georgia in 2010 to that in 2014?
Your response must be concise. 0.49. What is the ratio of the Borrowers(per 1000 adults) of Pakistan in 2010 to that in 2014?
Offer a very short reply. 1.15. What is the ratio of the Borrowers(per 1000 adults) of Poland in 2010 to that in 2014?
Your answer should be very brief. 1.06. What is the ratio of the Borrowers(per 1000 adults) in Zambia in 2010 to that in 2014?
Keep it short and to the point. 0.49. What is the ratio of the Borrowers(per 1000 adults) in Georgia in 2012 to that in 2013?
Ensure brevity in your answer.  0.78. What is the ratio of the Borrowers(per 1000 adults) of Pakistan in 2012 to that in 2013?
Provide a short and direct response. 1.05. What is the ratio of the Borrowers(per 1000 adults) in Poland in 2012 to that in 2013?
Offer a very short reply. 0.91. What is the ratio of the Borrowers(per 1000 adults) of Zambia in 2012 to that in 2013?
Provide a succinct answer. 1.01. What is the ratio of the Borrowers(per 1000 adults) in Georgia in 2012 to that in 2014?
Provide a short and direct response. 0.7. What is the ratio of the Borrowers(per 1000 adults) of Pakistan in 2012 to that in 2014?
Keep it short and to the point. 1.08. What is the ratio of the Borrowers(per 1000 adults) in Poland in 2012 to that in 2014?
Offer a very short reply. 0.81. What is the ratio of the Borrowers(per 1000 adults) in Zambia in 2012 to that in 2014?
Your answer should be very brief. 1.01. What is the ratio of the Borrowers(per 1000 adults) of Georgia in 2013 to that in 2014?
Provide a succinct answer. 0.89. What is the ratio of the Borrowers(per 1000 adults) in Pakistan in 2013 to that in 2014?
Offer a terse response. 1.03. What is the ratio of the Borrowers(per 1000 adults) of Poland in 2013 to that in 2014?
Your answer should be compact. 0.89. What is the difference between the highest and the second highest Borrowers(per 1000 adults) of Georgia?
Your answer should be compact. 65.44. What is the difference between the highest and the second highest Borrowers(per 1000 adults) in Pakistan?
Make the answer very short. 0.08. What is the difference between the highest and the second highest Borrowers(per 1000 adults) of Poland?
Keep it short and to the point. 17.07. What is the difference between the highest and the second highest Borrowers(per 1000 adults) of Zambia?
Your answer should be compact. 0.21. What is the difference between the highest and the lowest Borrowers(per 1000 adults) in Georgia?
Your answer should be very brief. 429.97. What is the difference between the highest and the lowest Borrowers(per 1000 adults) of Pakistan?
Your answer should be compact. 7.75. What is the difference between the highest and the lowest Borrowers(per 1000 adults) in Poland?
Offer a very short reply. 79.18. What is the difference between the highest and the lowest Borrowers(per 1000 adults) of Zambia?
Keep it short and to the point. 27.2. 